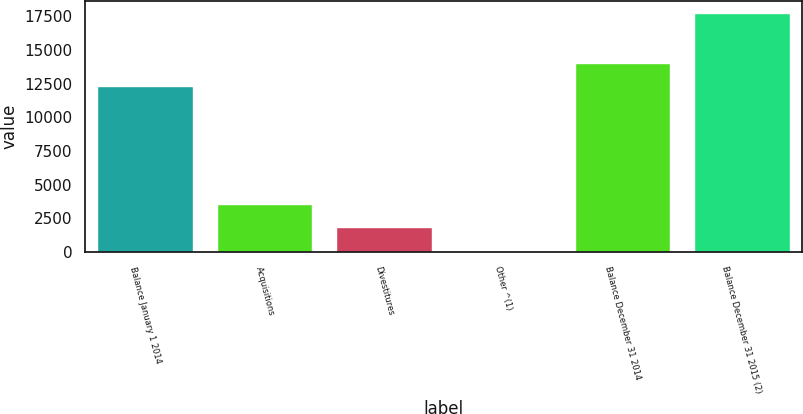Convert chart to OTSL. <chart><loc_0><loc_0><loc_500><loc_500><bar_chart><fcel>Balance January 1 2014<fcel>Acquisitions<fcel>Divestitures<fcel>Other ^(1)<fcel>Balance December 31 2014<fcel>Balance December 31 2015 (2)<nl><fcel>12301<fcel>3593.4<fcel>1827.2<fcel>61<fcel>14067.2<fcel>17723<nl></chart> 